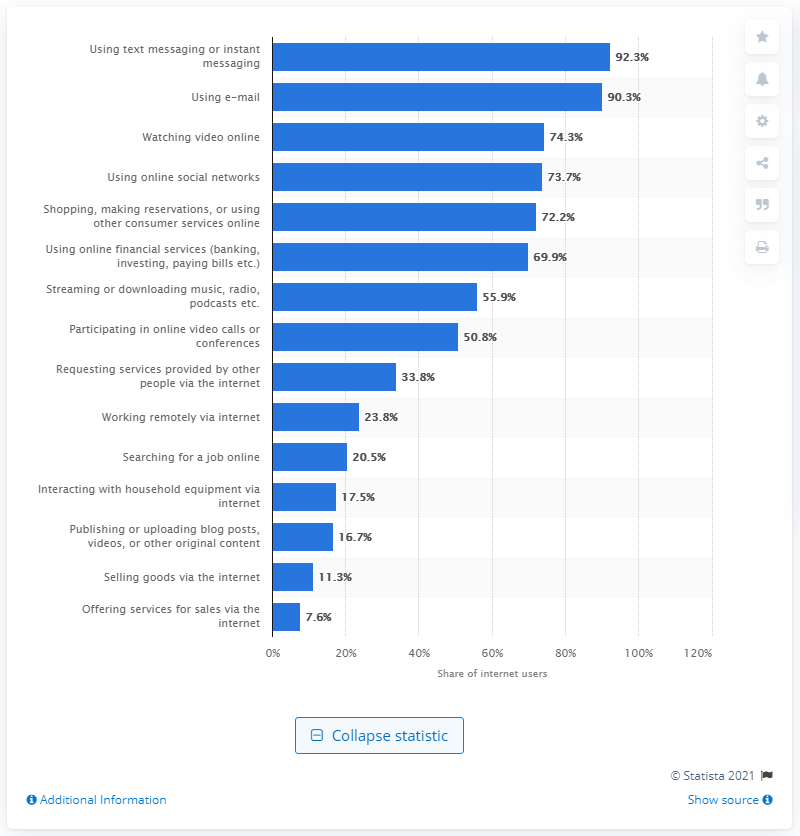List a handful of essential elements in this visual. As of November 2019, 74.3% of the online population in the United States had accessed social networks. 